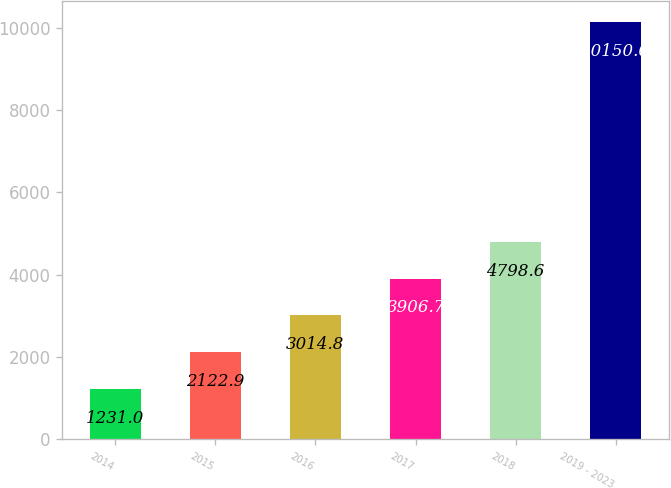Convert chart to OTSL. <chart><loc_0><loc_0><loc_500><loc_500><bar_chart><fcel>2014<fcel>2015<fcel>2016<fcel>2017<fcel>2018<fcel>2019 - 2023<nl><fcel>1231<fcel>2122.9<fcel>3014.8<fcel>3906.7<fcel>4798.6<fcel>10150<nl></chart> 